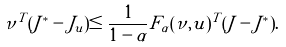Convert formula to latex. <formula><loc_0><loc_0><loc_500><loc_500>\nu ^ { T } ( J ^ { * } - J _ { \tilde { u } } ) \leq \frac { 1 } { 1 - \alpha } F _ { \alpha } ( \nu , \tilde { u } ) ^ { T } ( \tilde { J } - J ^ { * } ) .</formula> 